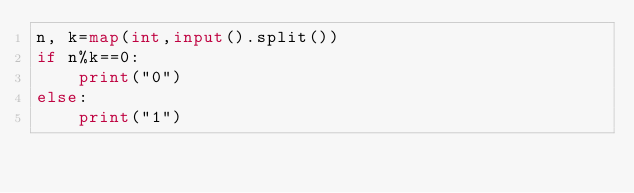<code> <loc_0><loc_0><loc_500><loc_500><_Python_>n, k=map(int,input().split())
if n%k==0:
    print("0")
else:
    print("1")</code> 